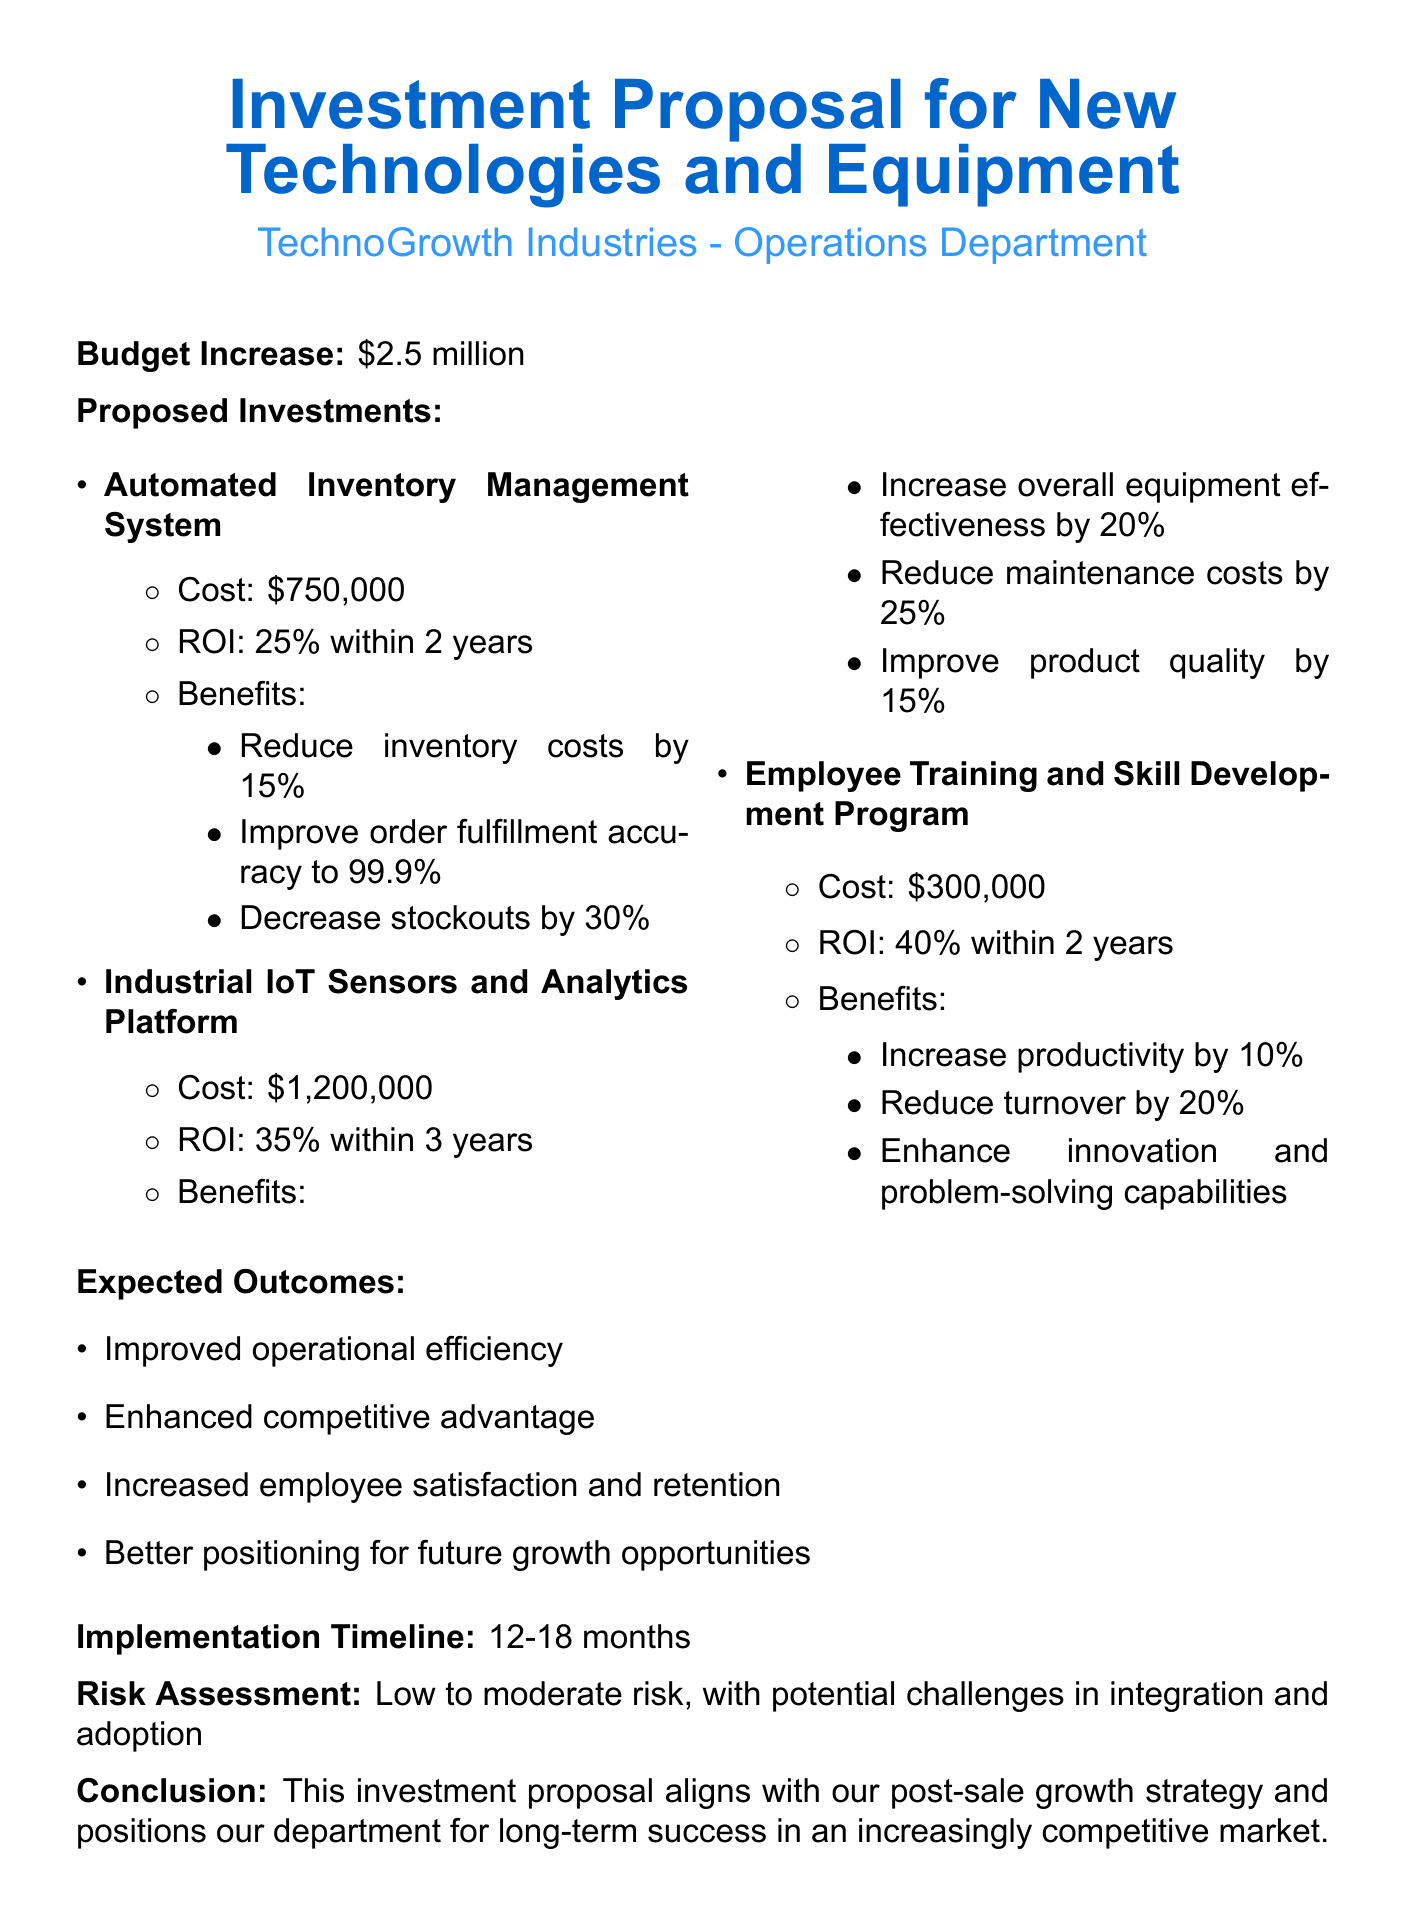What is the total budget increase? The total budget increase is stated at the beginning of the document as $2.5 million.
Answer: $2.5 million What is the cost of the Automated Inventory Management System? The cost for the Automated Inventory Management System is listed as $750,000.
Answer: $750,000 What is the expected ROI for the Industrial IoT Sensors and Analytics Platform? The expected ROI for the Industrial IoT Sensors and Analytics Platform is noted as 35% within 3 years.
Answer: 35% within 3 years What benefit does the Employee Training and Skill Development Program provide related to productivity? The benefit related to productivity is specifically stated as a 10% increase.
Answer: Increase productivity by 10% What is the implementation timeline for the proposed investments? The implementation timeline is mentioned in the document as 12-18 months.
Answer: 12-18 months What are the expected outcomes of these investments? The expected outcomes include multiple benefits, one of which is improved operational efficiency.
Answer: Improved operational efficiency What type of risks does the proposal identify? The proposal assesses the risk as low to moderate with challenges in integration and adoption.
Answer: Low to moderate risk Why is this investment proposal important for the department? The conclusion indicates that the proposal aligns with the post-sale growth strategy and positions the department for long-term success.
Answer: Aligns with our post-sale growth strategy 